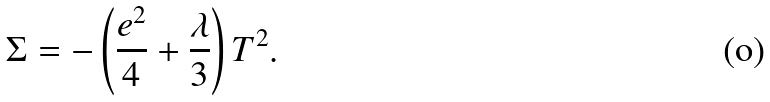<formula> <loc_0><loc_0><loc_500><loc_500>\Sigma = - \left ( \frac { e ^ { 2 } } { 4 } + \frac { \lambda } { 3 } \right ) T ^ { 2 } .</formula> 